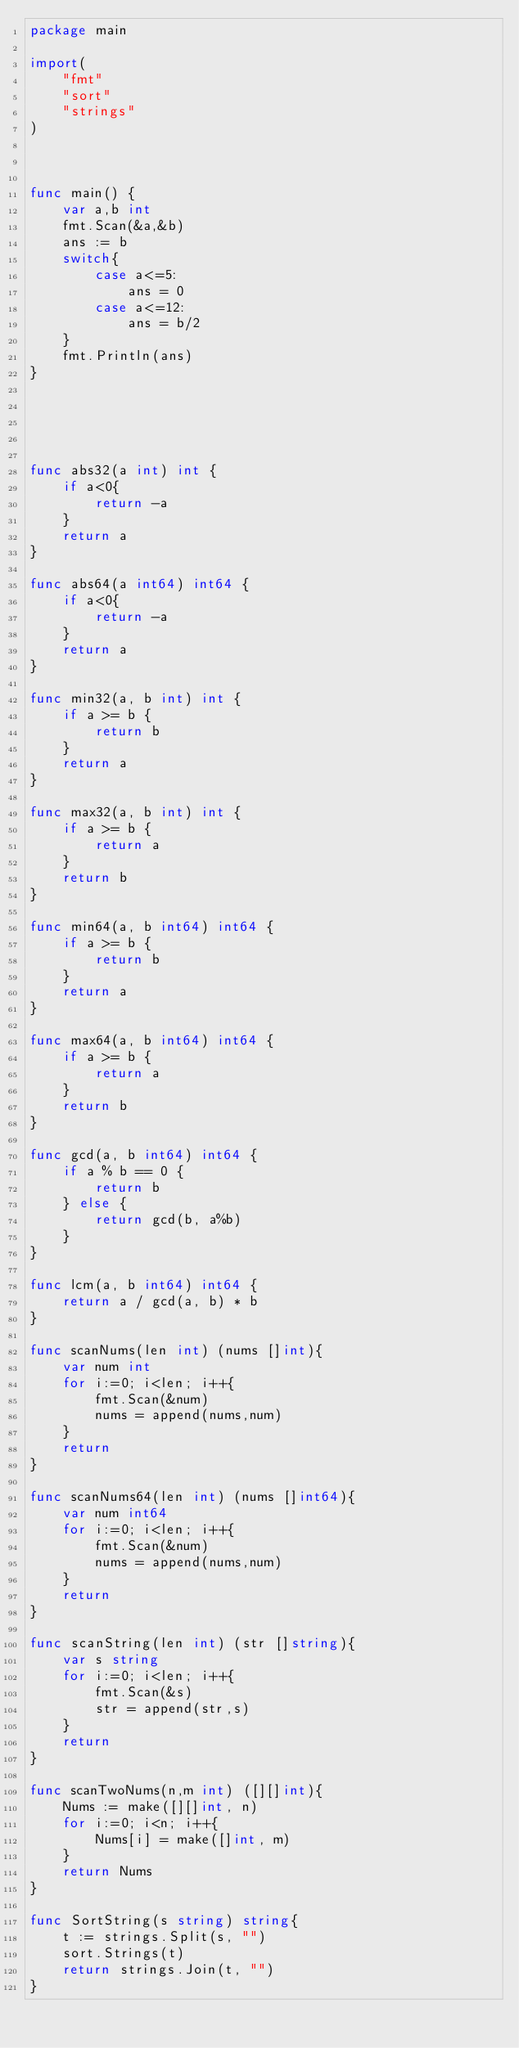<code> <loc_0><loc_0><loc_500><loc_500><_Go_>package main

import(
    "fmt"
    "sort"
    "strings"
)



func main() {
    var a,b int
    fmt.Scan(&a,&b)
    ans := b
    switch{
        case a<=5:
            ans = 0
        case a<=12:
            ans = b/2
    }
    fmt.Println(ans)
}





func abs32(a int) int {
    if a<0{
        return -a
    }
    return a
}

func abs64(a int64) int64 {
    if a<0{
        return -a
    }
    return a
}

func min32(a, b int) int {
    if a >= b {
        return b
    }
    return a
}

func max32(a, b int) int {
    if a >= b {
        return a
    }
    return b
}

func min64(a, b int64) int64 {
    if a >= b {
        return b
    }
    return a
}

func max64(a, b int64) int64 {
    if a >= b {
        return a
    }
    return b
}

func gcd(a, b int64) int64 {
    if a % b == 0 {
        return b
    } else {
        return gcd(b, a%b)
    }
}

func lcm(a, b int64) int64 {
    return a / gcd(a, b) * b
}

func scanNums(len int) (nums []int){
    var num int
    for i:=0; i<len; i++{
        fmt.Scan(&num)
        nums = append(nums,num)
    }
    return
}

func scanNums64(len int) (nums []int64){
    var num int64
    for i:=0; i<len; i++{
        fmt.Scan(&num)
        nums = append(nums,num)
    }
    return
}

func scanString(len int) (str []string){
    var s string
    for i:=0; i<len; i++{
        fmt.Scan(&s)
        str = append(str,s)
    }
    return
}

func scanTwoNums(n,m int) ([][]int){
    Nums := make([][]int, n)
    for i:=0; i<n; i++{
        Nums[i] = make([]int, m)
    }
    return Nums
}

func SortString(s string) string{
    t := strings.Split(s, "")
    sort.Strings(t)
    return strings.Join(t, "")
}
</code> 